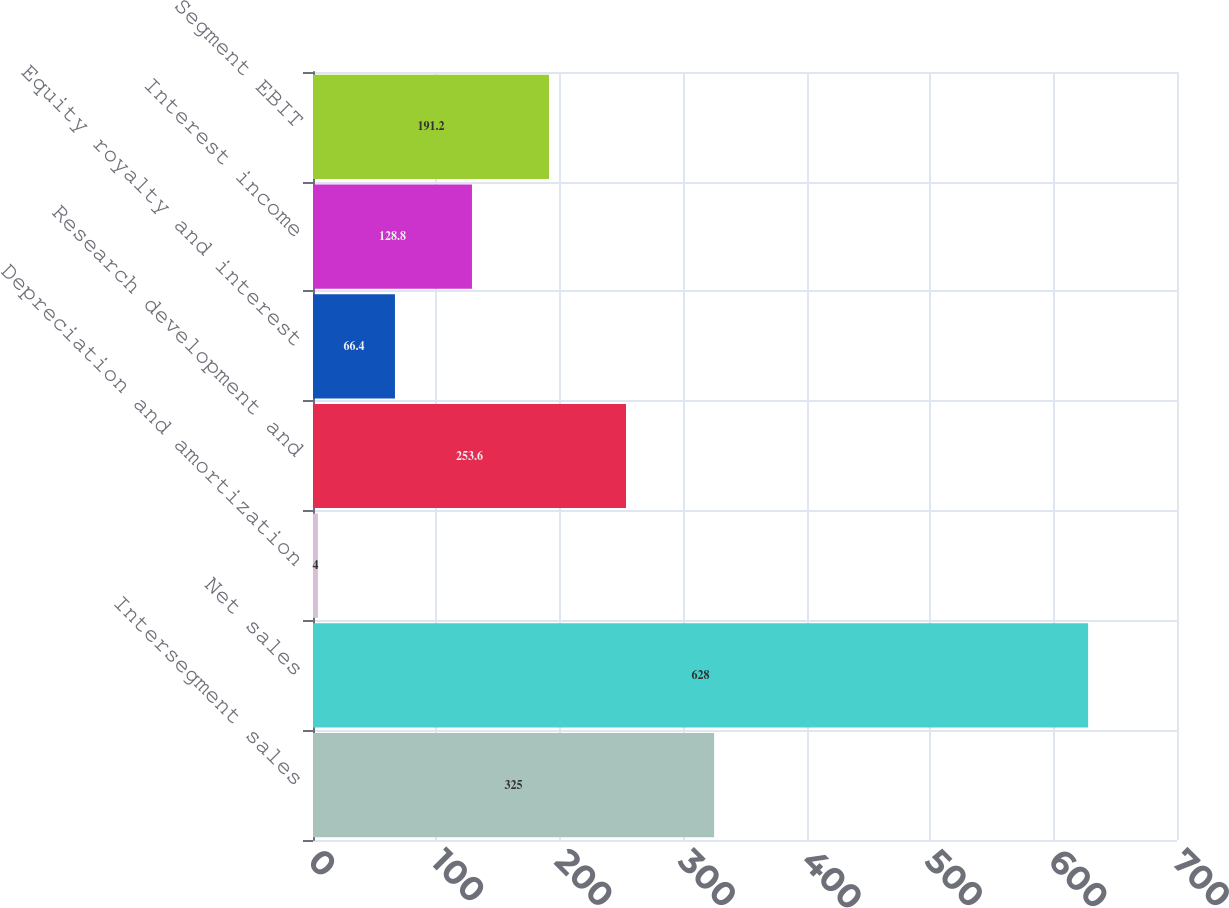Convert chart. <chart><loc_0><loc_0><loc_500><loc_500><bar_chart><fcel>Intersegment sales<fcel>Net sales<fcel>Depreciation and amortization<fcel>Research development and<fcel>Equity royalty and interest<fcel>Interest income<fcel>Segment EBIT<nl><fcel>325<fcel>628<fcel>4<fcel>253.6<fcel>66.4<fcel>128.8<fcel>191.2<nl></chart> 